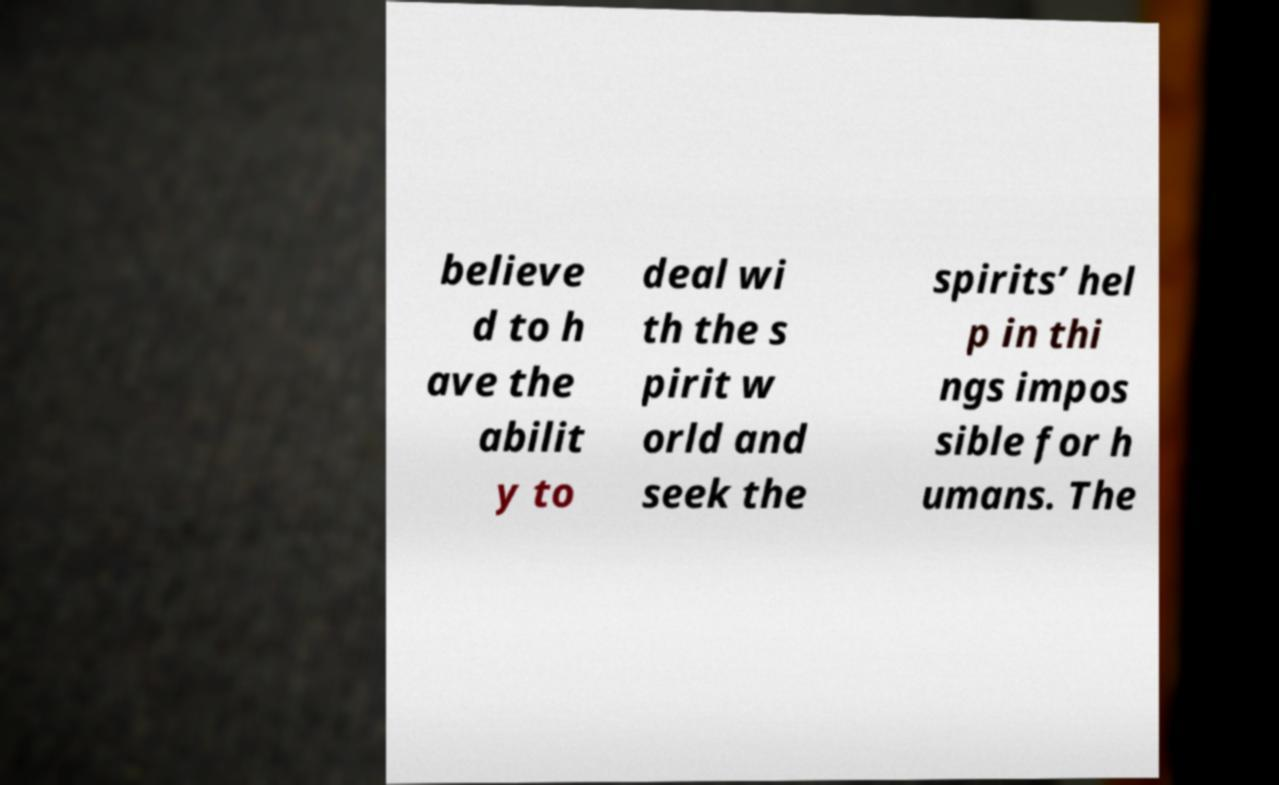Please read and relay the text visible in this image. What does it say? believe d to h ave the abilit y to deal wi th the s pirit w orld and seek the spirits’ hel p in thi ngs impos sible for h umans. The 